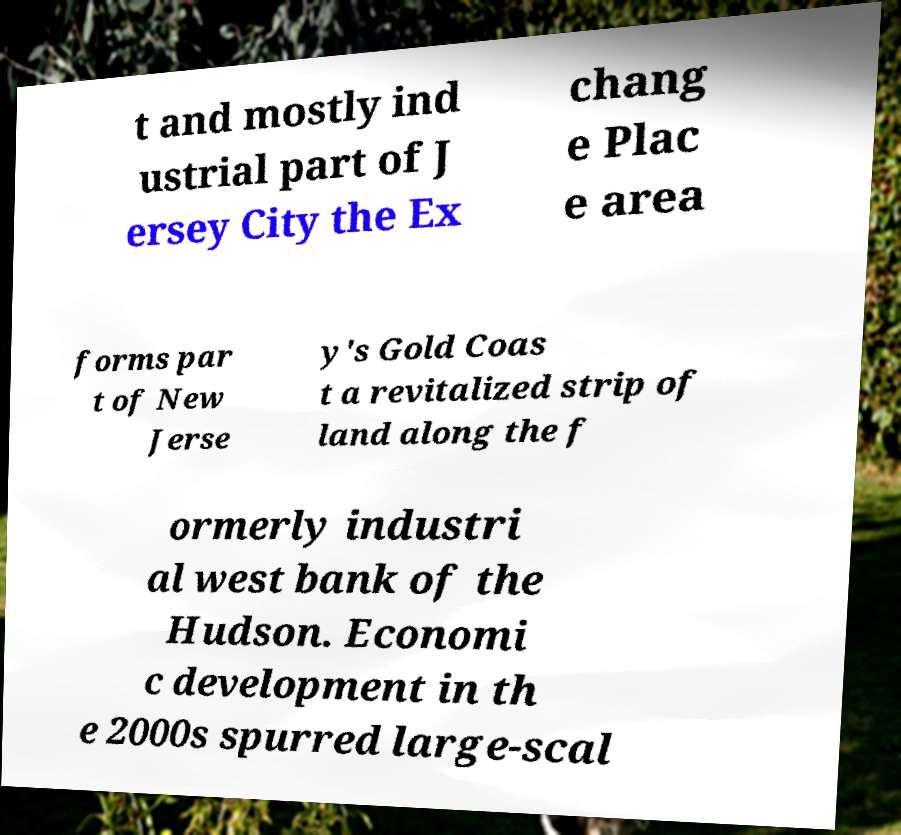Could you assist in decoding the text presented in this image and type it out clearly? t and mostly ind ustrial part of J ersey City the Ex chang e Plac e area forms par t of New Jerse y's Gold Coas t a revitalized strip of land along the f ormerly industri al west bank of the Hudson. Economi c development in th e 2000s spurred large-scal 